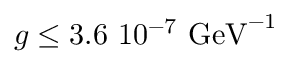Convert formula to latex. <formula><loc_0><loc_0><loc_500><loc_500>g \leq 3 . 6 \ 1 0 ^ { - 7 } \ G e V ^ { - 1 }</formula> 